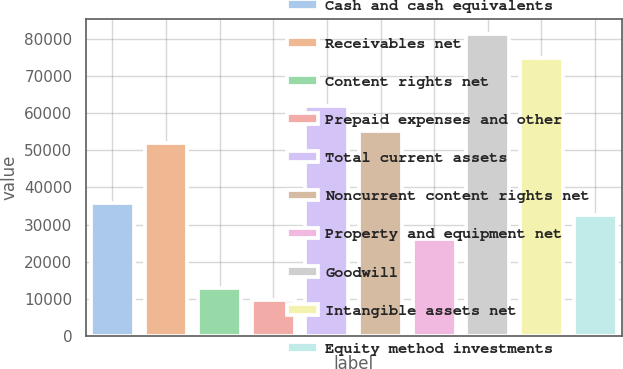Convert chart. <chart><loc_0><loc_0><loc_500><loc_500><bar_chart><fcel>Cash and cash equivalents<fcel>Receivables net<fcel>Content rights net<fcel>Prepaid expenses and other<fcel>Total current assets<fcel>Noncurrent content rights net<fcel>Property and equipment net<fcel>Goodwill<fcel>Intangible assets net<fcel>Equity method investments<nl><fcel>35804.8<fcel>52078.8<fcel>13021.2<fcel>9766.4<fcel>61843.2<fcel>55333.6<fcel>26040.4<fcel>81372<fcel>74862.4<fcel>32550<nl></chart> 